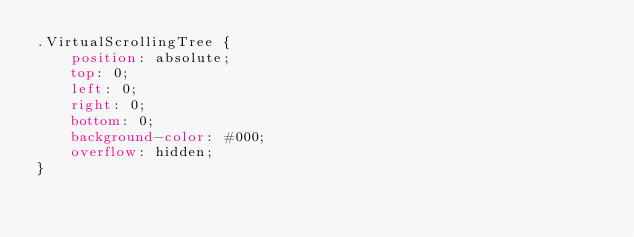<code> <loc_0><loc_0><loc_500><loc_500><_CSS_>.VirtualScrollingTree {
    position: absolute;
    top: 0;
    left: 0;
    right: 0;
    bottom: 0;
    background-color: #000;
    overflow: hidden;
}</code> 